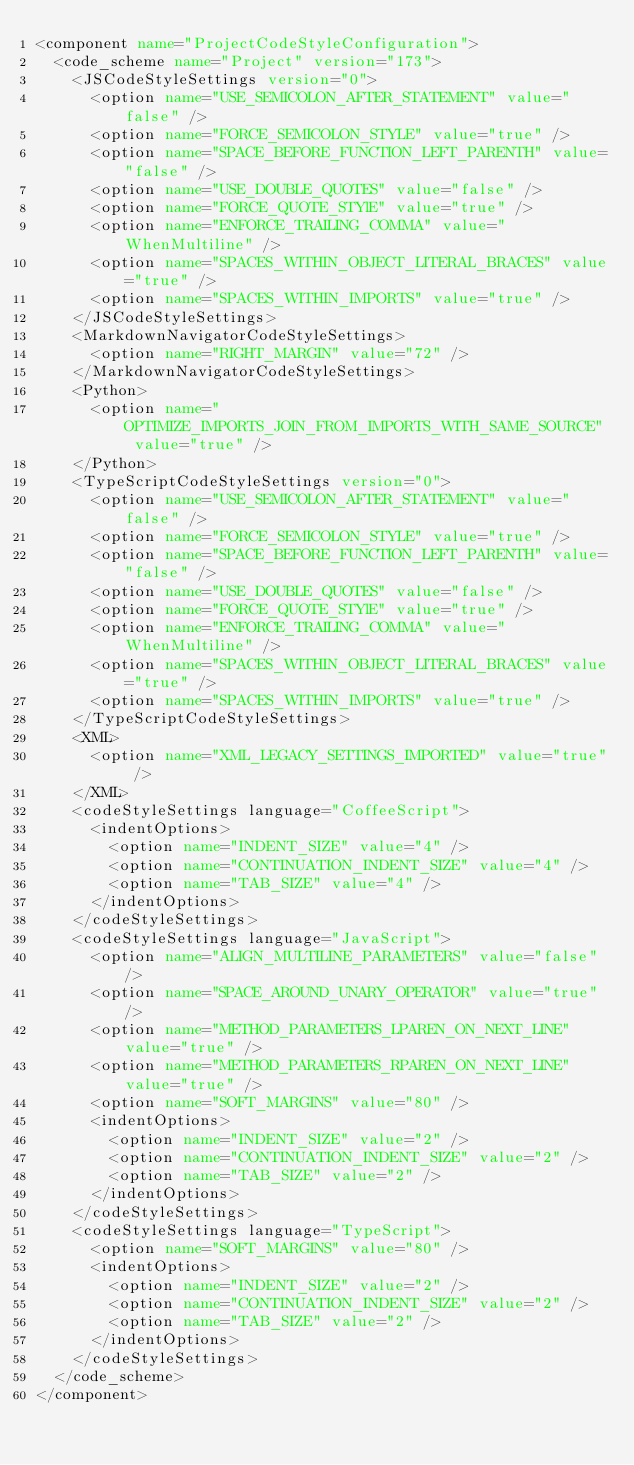Convert code to text. <code><loc_0><loc_0><loc_500><loc_500><_XML_><component name="ProjectCodeStyleConfiguration">
  <code_scheme name="Project" version="173">
    <JSCodeStyleSettings version="0">
      <option name="USE_SEMICOLON_AFTER_STATEMENT" value="false" />
      <option name="FORCE_SEMICOLON_STYLE" value="true" />
      <option name="SPACE_BEFORE_FUNCTION_LEFT_PARENTH" value="false" />
      <option name="USE_DOUBLE_QUOTES" value="false" />
      <option name="FORCE_QUOTE_STYlE" value="true" />
      <option name="ENFORCE_TRAILING_COMMA" value="WhenMultiline" />
      <option name="SPACES_WITHIN_OBJECT_LITERAL_BRACES" value="true" />
      <option name="SPACES_WITHIN_IMPORTS" value="true" />
    </JSCodeStyleSettings>
    <MarkdownNavigatorCodeStyleSettings>
      <option name="RIGHT_MARGIN" value="72" />
    </MarkdownNavigatorCodeStyleSettings>
    <Python>
      <option name="OPTIMIZE_IMPORTS_JOIN_FROM_IMPORTS_WITH_SAME_SOURCE" value="true" />
    </Python>
    <TypeScriptCodeStyleSettings version="0">
      <option name="USE_SEMICOLON_AFTER_STATEMENT" value="false" />
      <option name="FORCE_SEMICOLON_STYLE" value="true" />
      <option name="SPACE_BEFORE_FUNCTION_LEFT_PARENTH" value="false" />
      <option name="USE_DOUBLE_QUOTES" value="false" />
      <option name="FORCE_QUOTE_STYlE" value="true" />
      <option name="ENFORCE_TRAILING_COMMA" value="WhenMultiline" />
      <option name="SPACES_WITHIN_OBJECT_LITERAL_BRACES" value="true" />
      <option name="SPACES_WITHIN_IMPORTS" value="true" />
    </TypeScriptCodeStyleSettings>
    <XML>
      <option name="XML_LEGACY_SETTINGS_IMPORTED" value="true" />
    </XML>
    <codeStyleSettings language="CoffeeScript">
      <indentOptions>
        <option name="INDENT_SIZE" value="4" />
        <option name="CONTINUATION_INDENT_SIZE" value="4" />
        <option name="TAB_SIZE" value="4" />
      </indentOptions>
    </codeStyleSettings>
    <codeStyleSettings language="JavaScript">
      <option name="ALIGN_MULTILINE_PARAMETERS" value="false" />
      <option name="SPACE_AROUND_UNARY_OPERATOR" value="true" />
      <option name="METHOD_PARAMETERS_LPAREN_ON_NEXT_LINE" value="true" />
      <option name="METHOD_PARAMETERS_RPAREN_ON_NEXT_LINE" value="true" />
      <option name="SOFT_MARGINS" value="80" />
      <indentOptions>
        <option name="INDENT_SIZE" value="2" />
        <option name="CONTINUATION_INDENT_SIZE" value="2" />
        <option name="TAB_SIZE" value="2" />
      </indentOptions>
    </codeStyleSettings>
    <codeStyleSettings language="TypeScript">
      <option name="SOFT_MARGINS" value="80" />
      <indentOptions>
        <option name="INDENT_SIZE" value="2" />
        <option name="CONTINUATION_INDENT_SIZE" value="2" />
        <option name="TAB_SIZE" value="2" />
      </indentOptions>
    </codeStyleSettings>
  </code_scheme>
</component></code> 